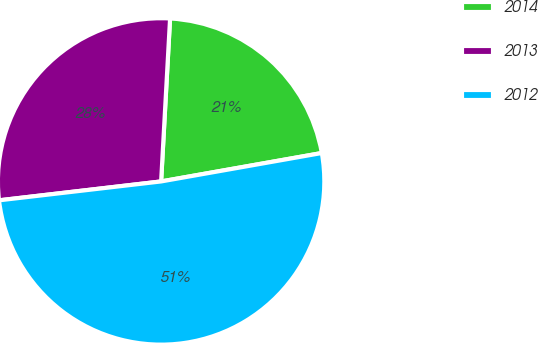Convert chart. <chart><loc_0><loc_0><loc_500><loc_500><pie_chart><fcel>2014<fcel>2013<fcel>2012<nl><fcel>21.34%<fcel>27.72%<fcel>50.94%<nl></chart> 